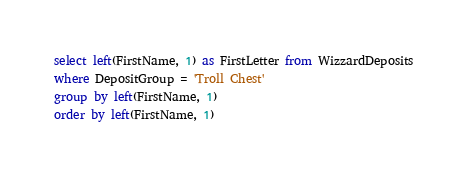<code> <loc_0><loc_0><loc_500><loc_500><_SQL_>select left(FirstName, 1) as FirstLetter from WizzardDeposits
where DepositGroup = 'Troll Chest'
group by left(FirstName, 1)
order by left(FirstName, 1)</code> 